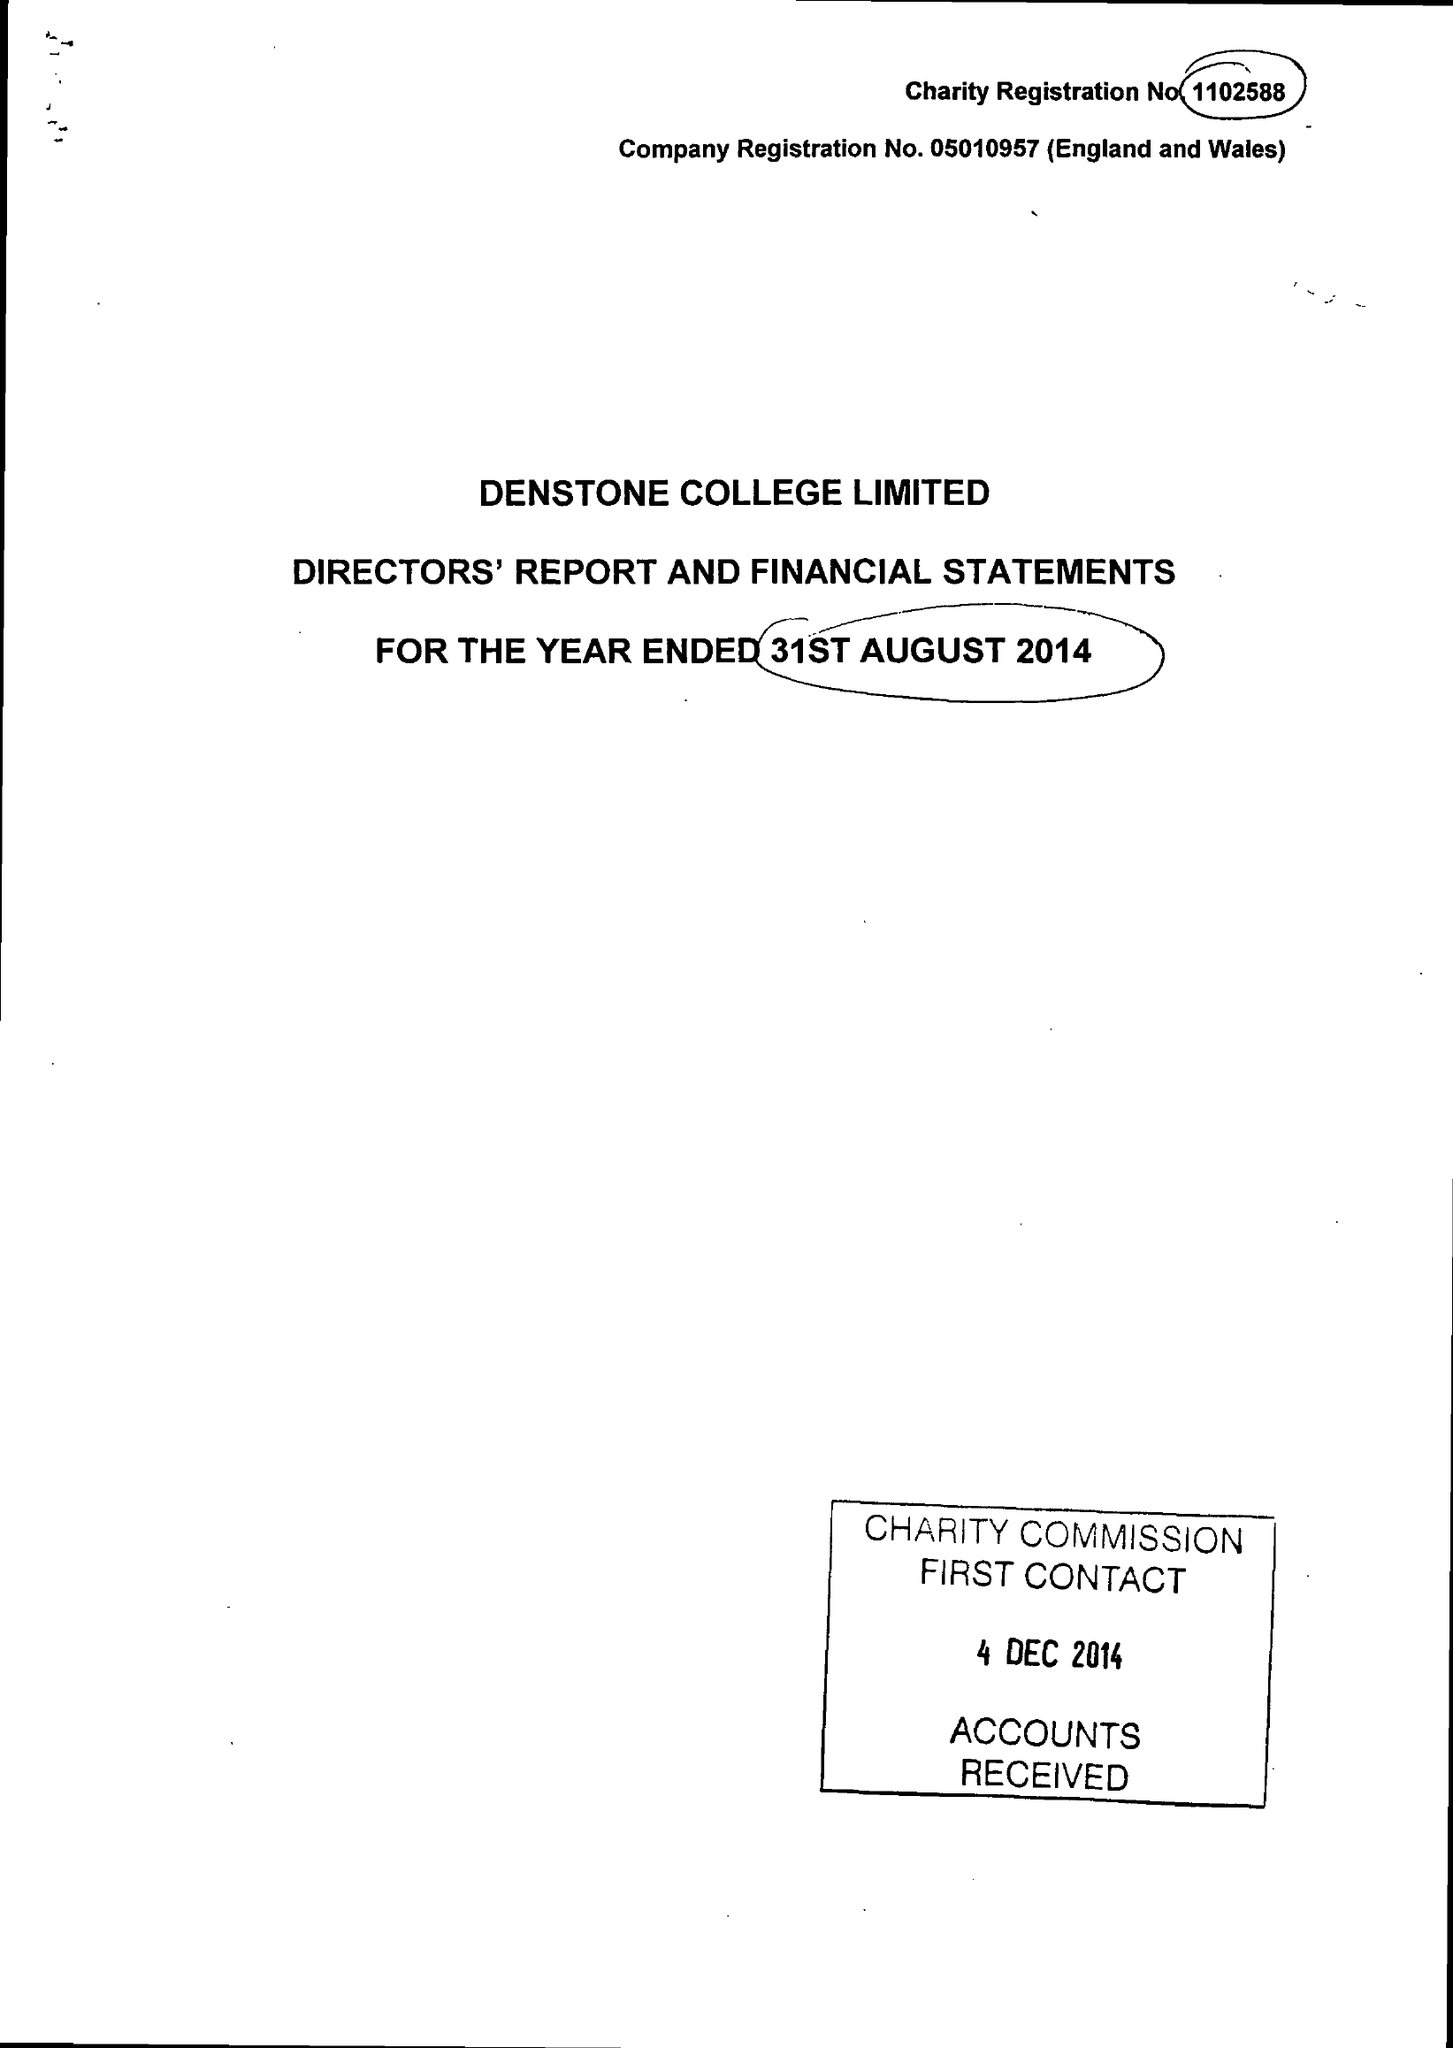What is the value for the address__post_town?
Answer the question using a single word or phrase. UTTOXETER 